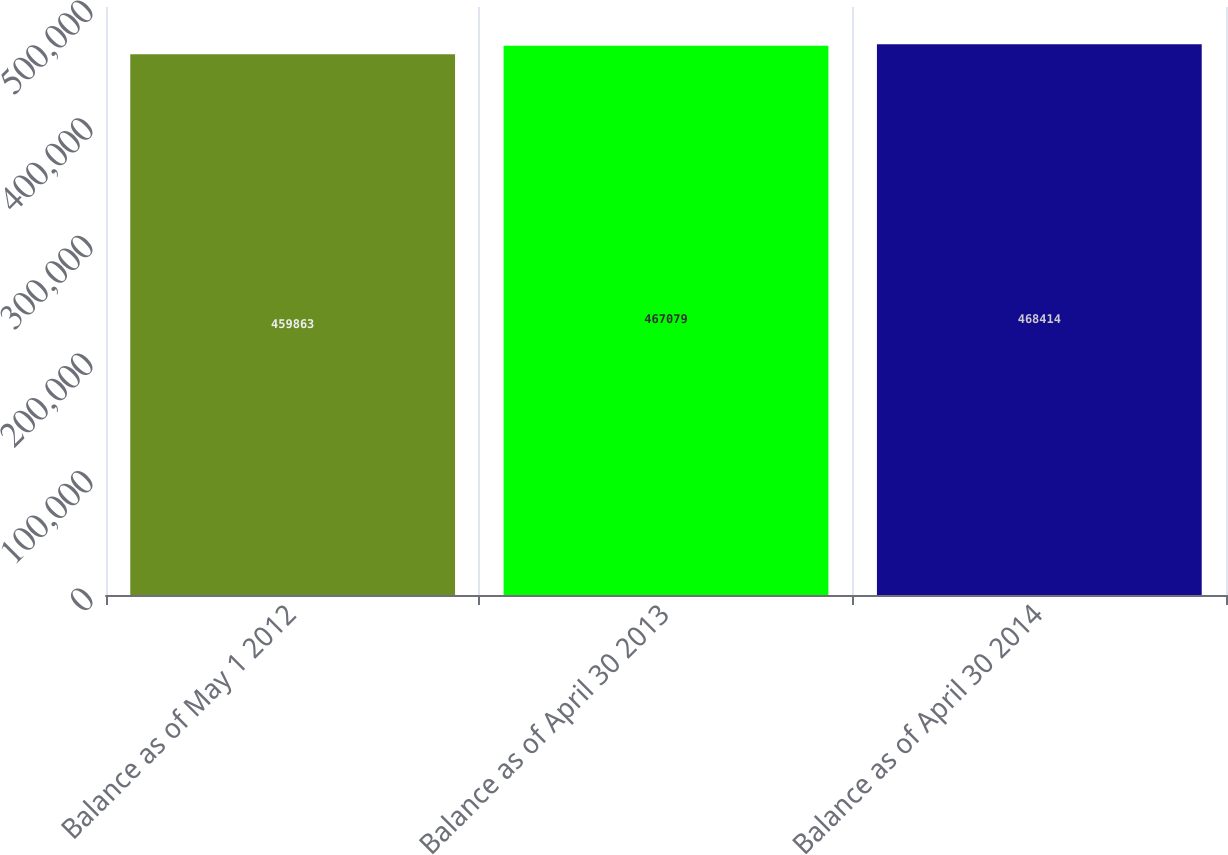Convert chart to OTSL. <chart><loc_0><loc_0><loc_500><loc_500><bar_chart><fcel>Balance as of May 1 2012<fcel>Balance as of April 30 2013<fcel>Balance as of April 30 2014<nl><fcel>459863<fcel>467079<fcel>468414<nl></chart> 